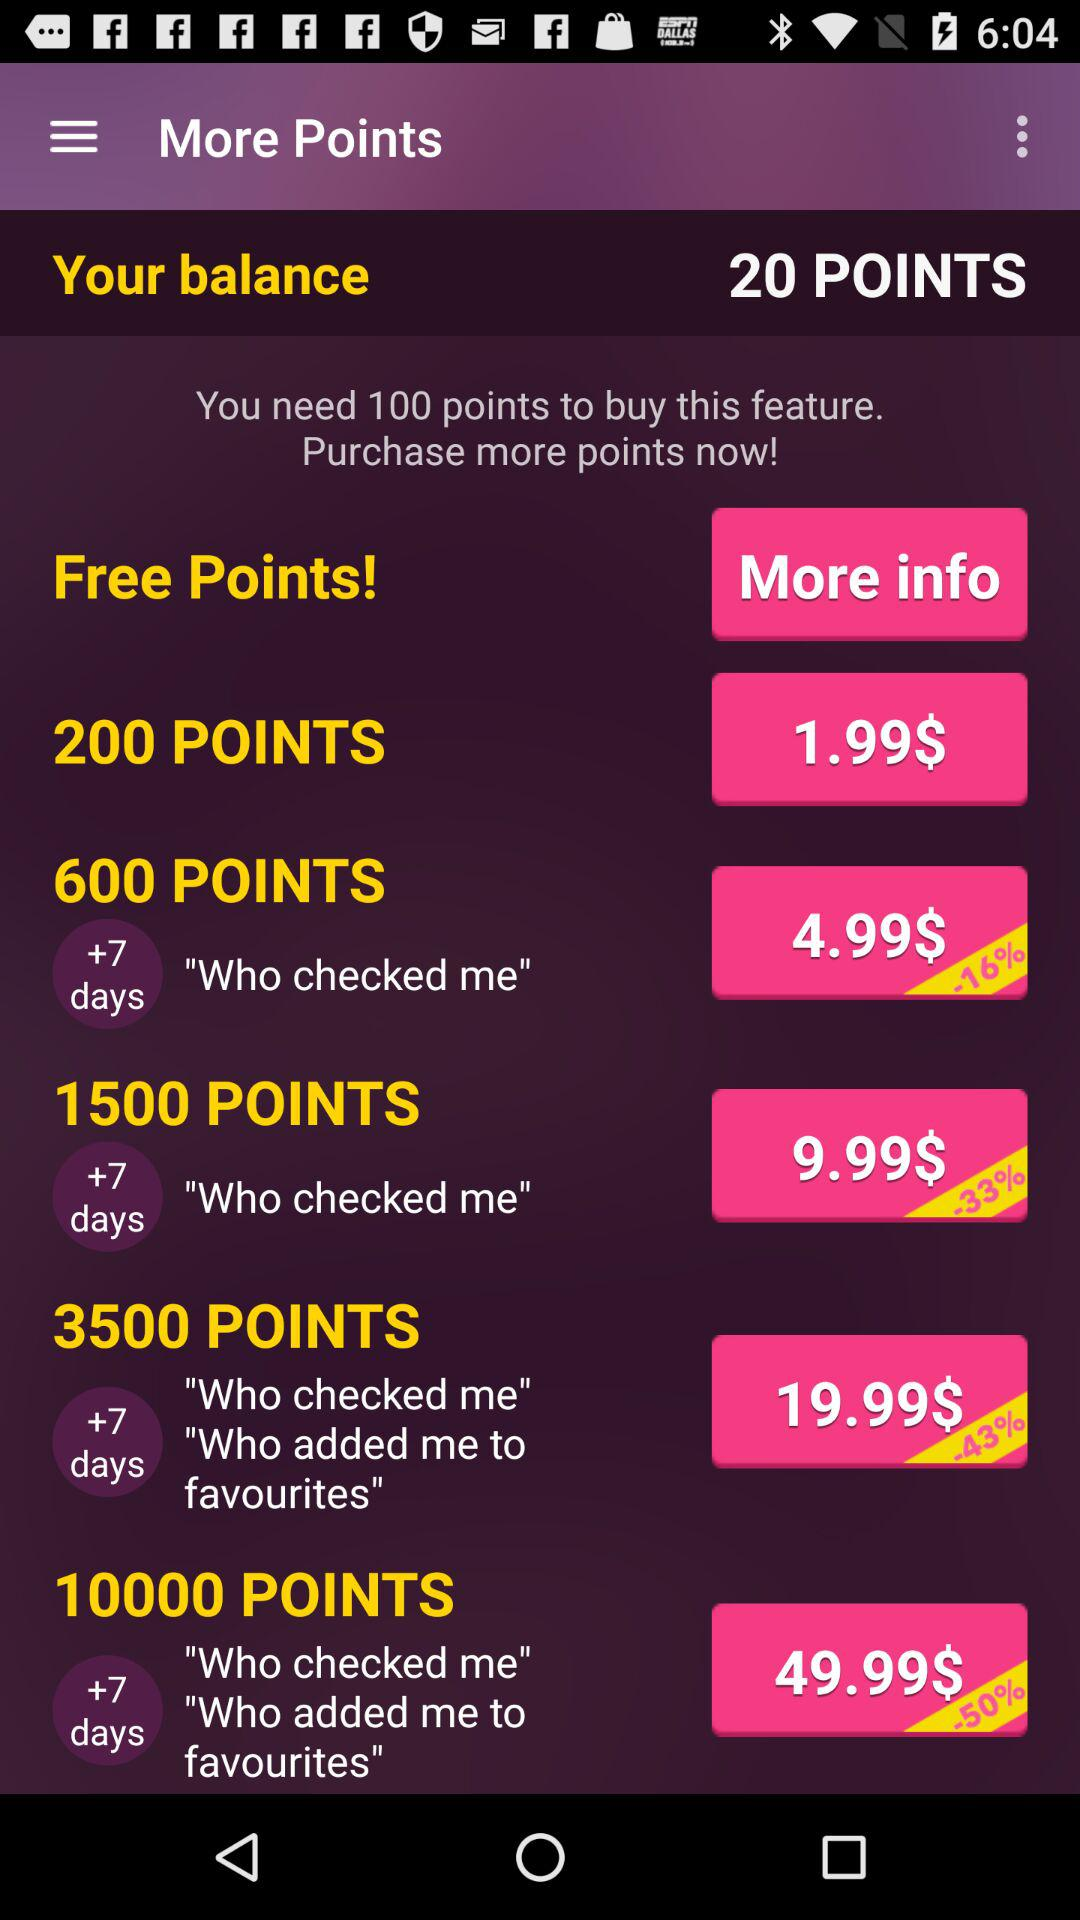What is the amount for 3500 points? The amount for 3500 points is 19.99$. 